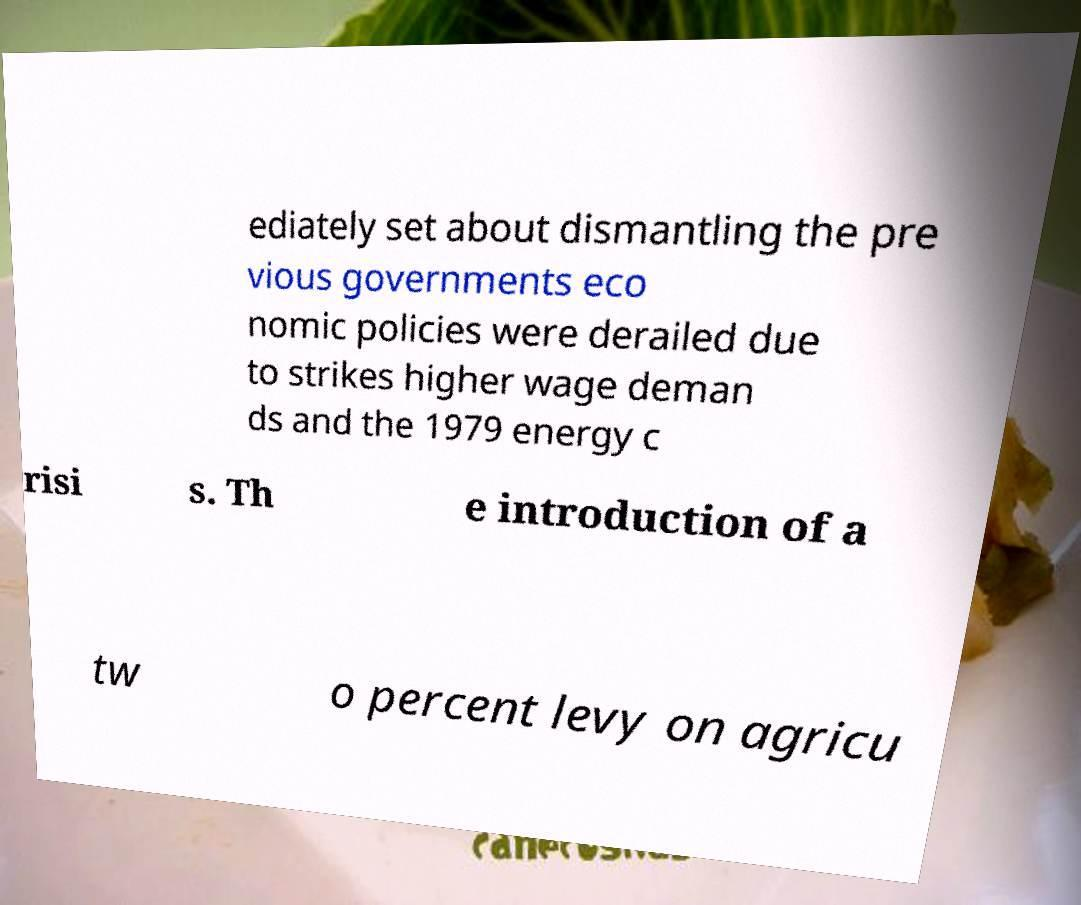Can you read and provide the text displayed in the image?This photo seems to have some interesting text. Can you extract and type it out for me? ediately set about dismantling the pre vious governments eco nomic policies were derailed due to strikes higher wage deman ds and the 1979 energy c risi s. Th e introduction of a tw o percent levy on agricu 